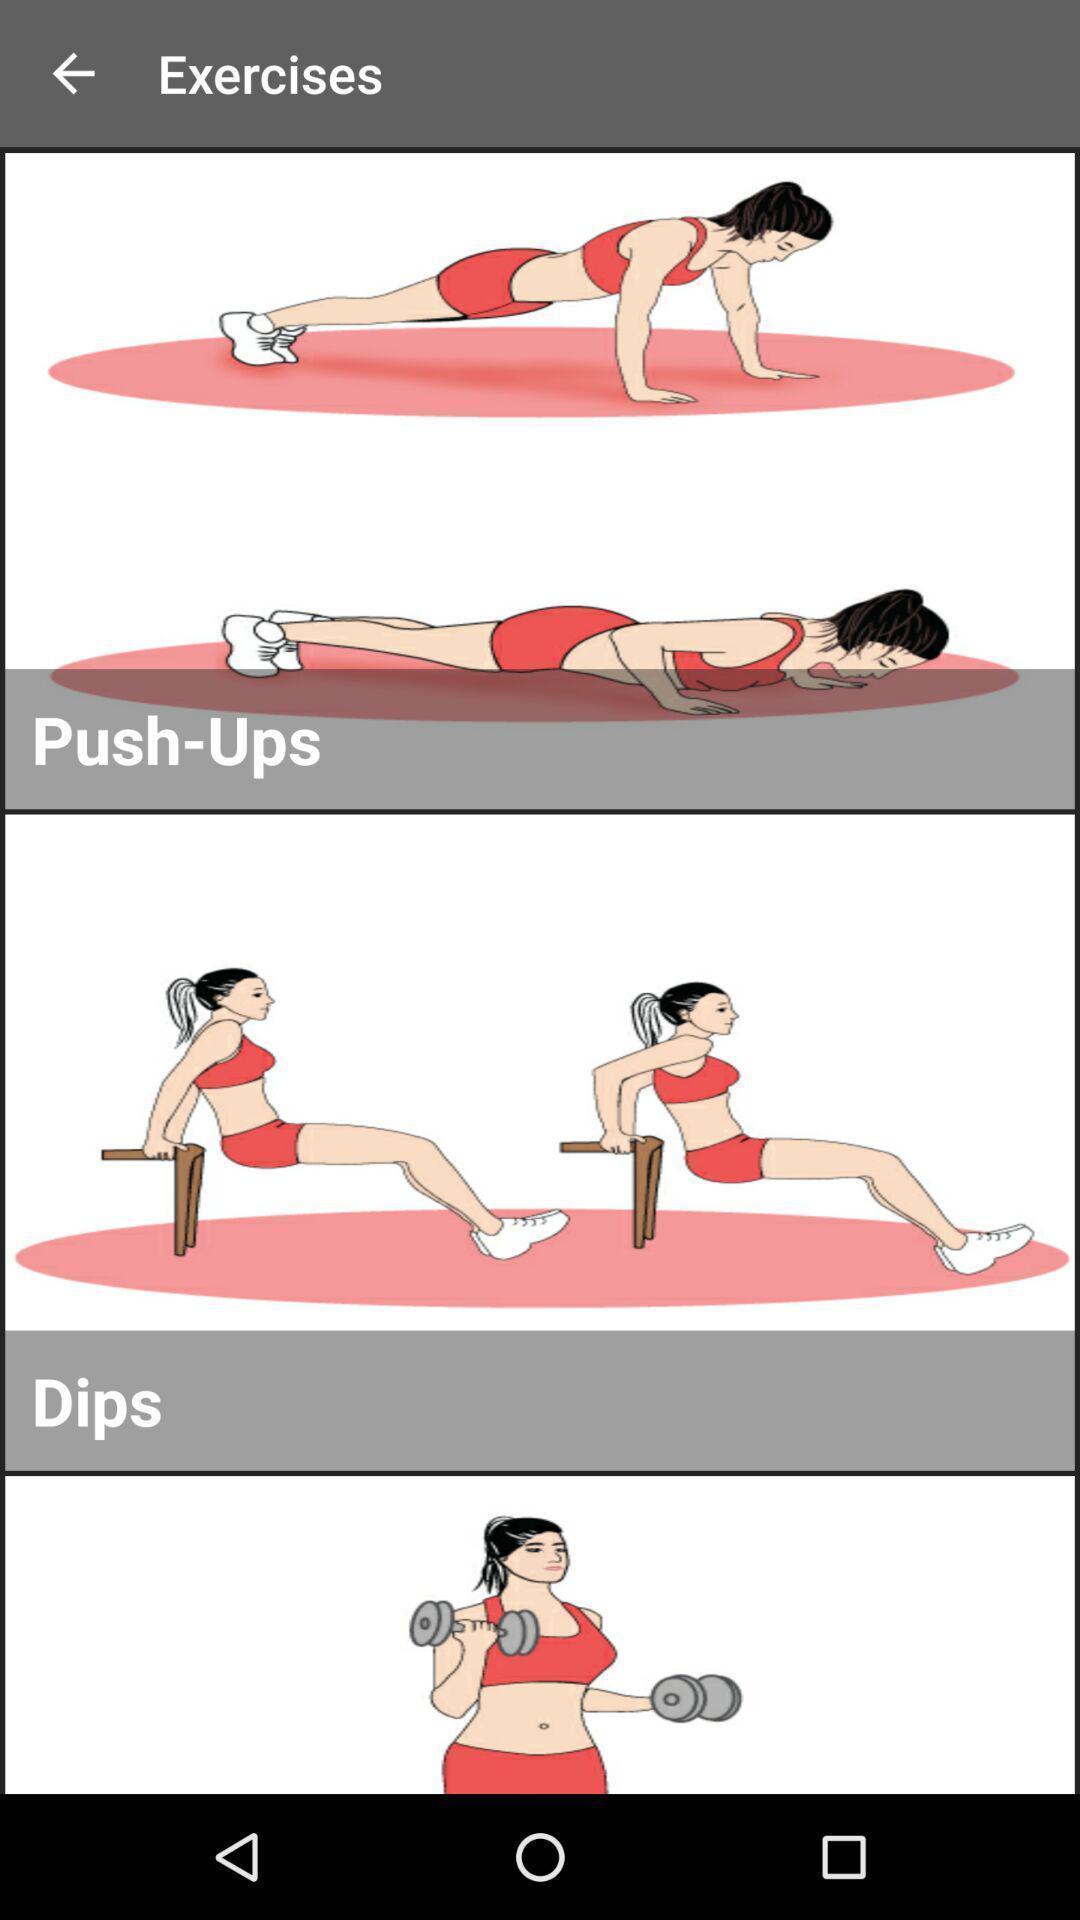Explain what's happening in this screen capture. Screen page of a fitness application. 